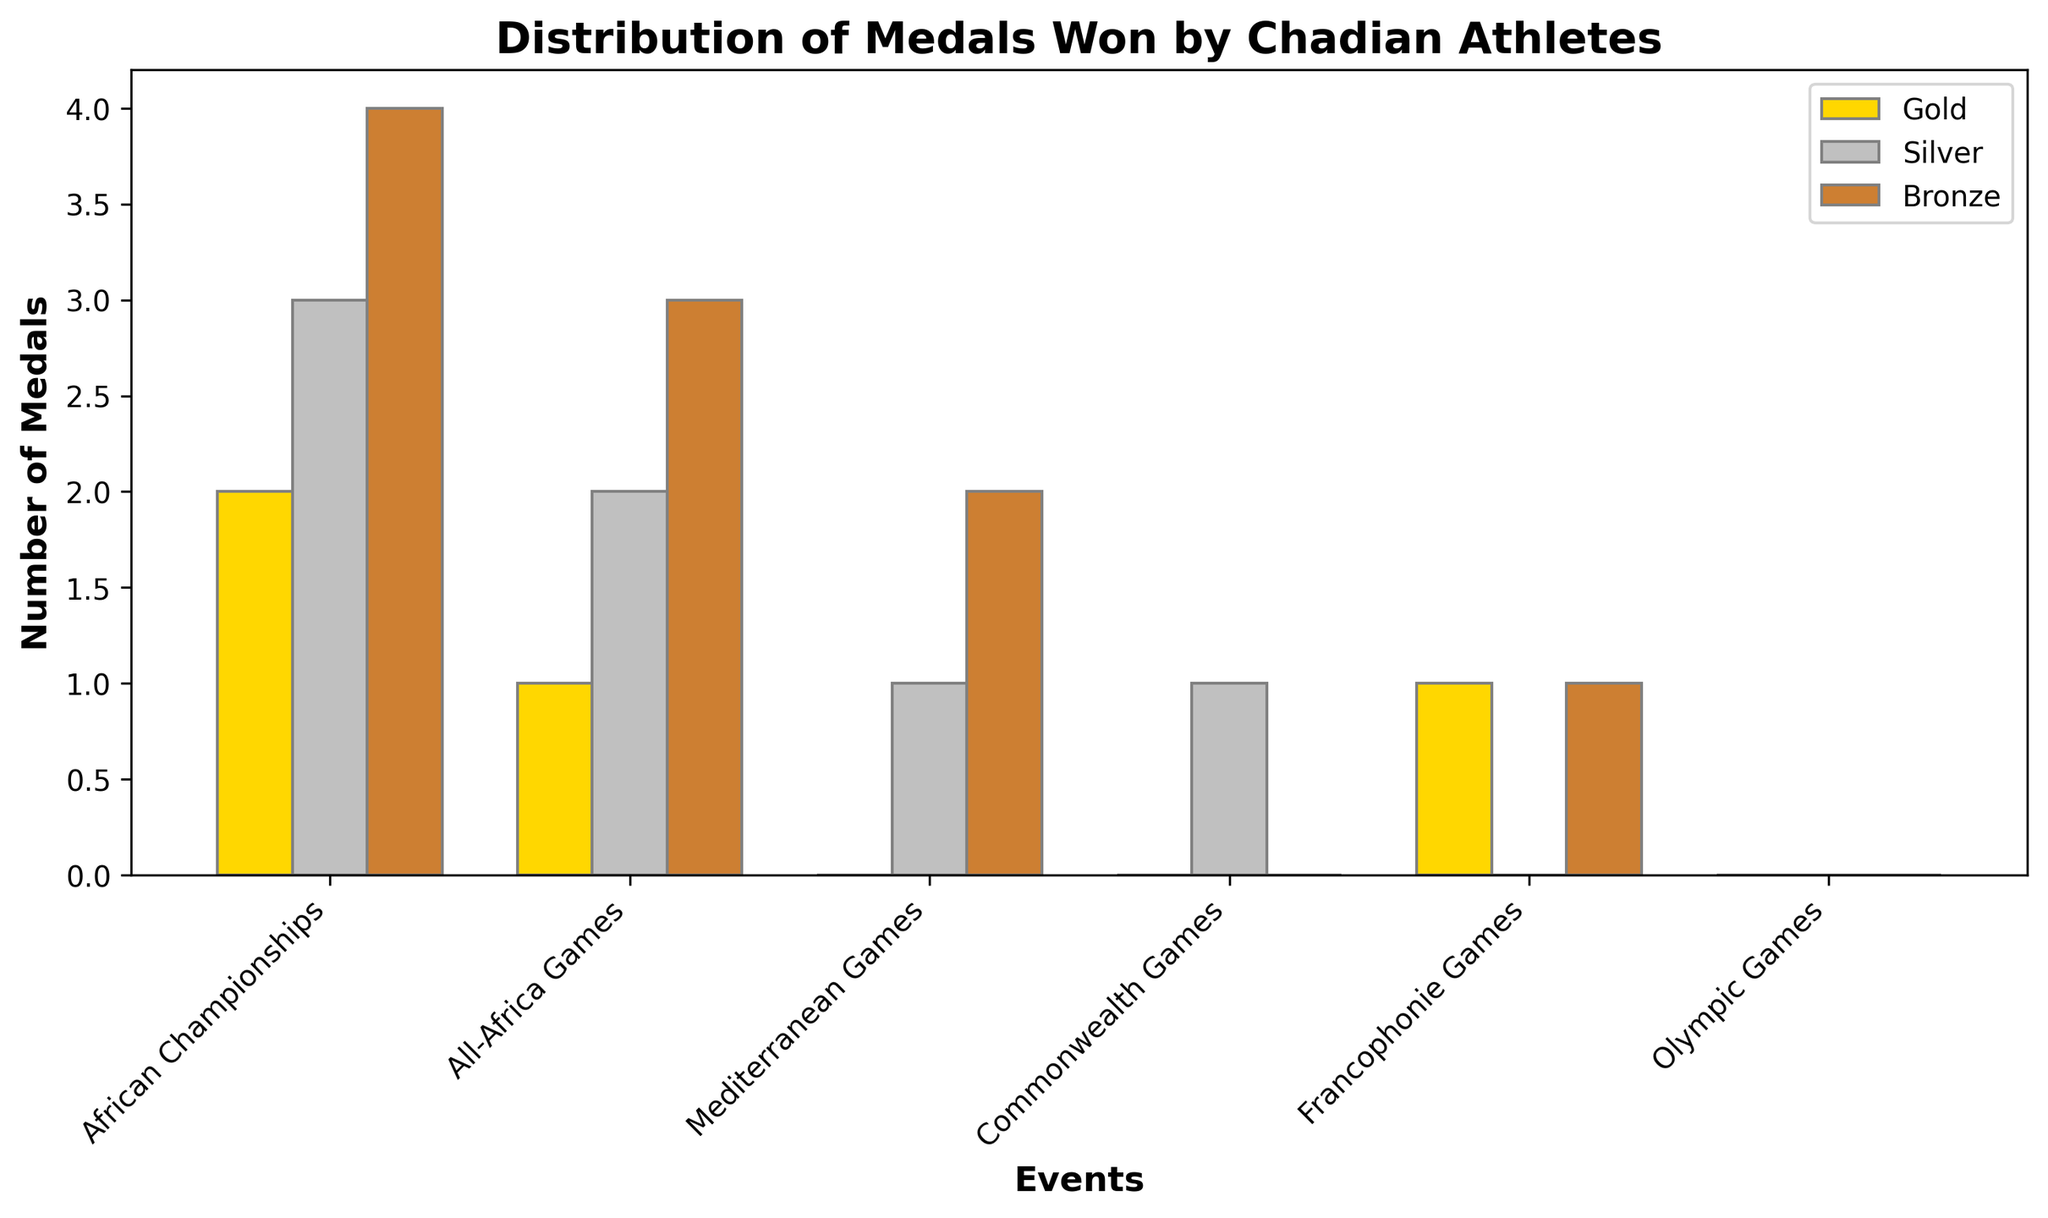Which event has the highest number of gold medals won by Chadian athletes? In the bar chart, the African Championships has the tallest gold bar, indicating it has the highest number of gold medals.
Answer: African Championships Which event has more silver medals: Commonwealth Games or Francophonie Games? From the bar chart, the silver bar for Commonwealth Games is taller than the silver bar for Francophonie Games.
Answer: Commonwealth Games How many total medals have Chadian athletes won in the All-Africa Games? Sum the gold, silver, and bronze medals for All-Africa Games: 1 (Gold) + 2 (Silver) + 3 (Bronze) = 6
Answer: 6 Which event has the lowest number of total medals won by Chadian athletes? Look for the event with the shortest combined gold, silver, and bronze bars. The Olympic Games has zero medals of all types.
Answer: Olympic Games How does the number of gold medals in African Championships compare to the bronze medals in the same event? The number of gold medals (2) is less than the number of bronze medals (4) in African Championships.
Answer: Less than What is the difference in the number of silver medals between African Championships and All-Africa Games? Subtract the number of silver medals in All-Africa Games (2) from those in African Championships (3): 3 - 2 = 1
Answer: 1 Which event has the same number of bronze medals as Commonwealth Games and Francophonie Games combined? Commonwealth Games (0) + Francophonie Games (1) = 1; Mediterranean Games also has 1 bronze medal.
Answer: Mediterranean Games How many total silver and bronze medals have Chadian athletes won across all events? Sum the silver (3 + 2 + 1 + 1 + 0 + 0 = 7) and bronze (4 + 3 + 2 + 0 + 1 + 0 = 10): 7 + 10 = 17
Answer: 17 